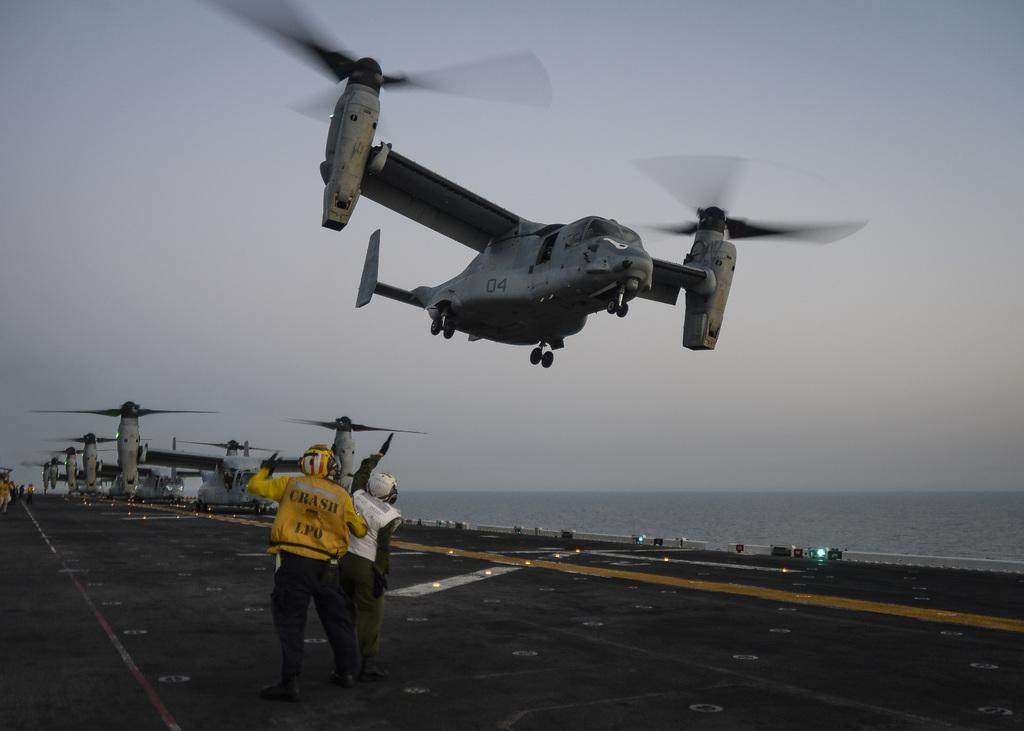<image>
Present a compact description of the photo's key features. A man in a yellow crash jacket assisting the planes in take-off. 